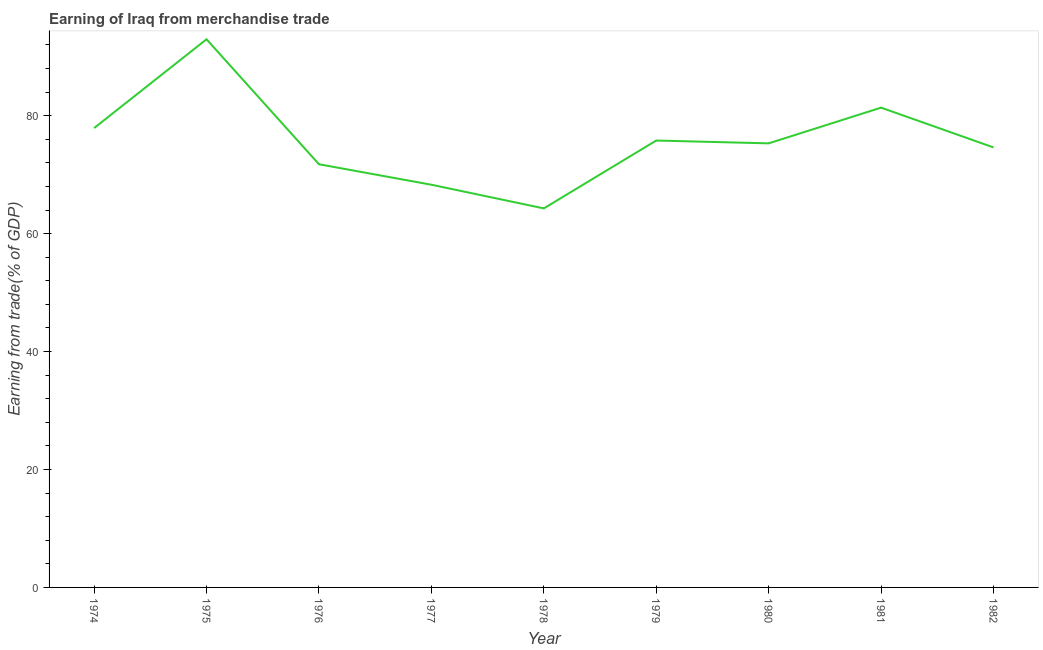What is the earning from merchandise trade in 1981?
Ensure brevity in your answer.  81.37. Across all years, what is the maximum earning from merchandise trade?
Ensure brevity in your answer.  92.96. Across all years, what is the minimum earning from merchandise trade?
Provide a succinct answer. 64.28. In which year was the earning from merchandise trade maximum?
Give a very brief answer. 1975. In which year was the earning from merchandise trade minimum?
Your response must be concise. 1978. What is the sum of the earning from merchandise trade?
Ensure brevity in your answer.  682.29. What is the difference between the earning from merchandise trade in 1977 and 1981?
Give a very brief answer. -13.07. What is the average earning from merchandise trade per year?
Offer a terse response. 75.81. What is the median earning from merchandise trade?
Make the answer very short. 75.31. Do a majority of the years between 1979 and 1981 (inclusive) have earning from merchandise trade greater than 40 %?
Ensure brevity in your answer.  Yes. What is the ratio of the earning from merchandise trade in 1974 to that in 1980?
Provide a short and direct response. 1.03. Is the earning from merchandise trade in 1977 less than that in 1981?
Make the answer very short. Yes. Is the difference between the earning from merchandise trade in 1977 and 1980 greater than the difference between any two years?
Give a very brief answer. No. What is the difference between the highest and the second highest earning from merchandise trade?
Keep it short and to the point. 11.59. Is the sum of the earning from merchandise trade in 1976 and 1980 greater than the maximum earning from merchandise trade across all years?
Your response must be concise. Yes. What is the difference between the highest and the lowest earning from merchandise trade?
Offer a terse response. 28.68. Does the earning from merchandise trade monotonically increase over the years?
Keep it short and to the point. No. How many lines are there?
Provide a short and direct response. 1. Are the values on the major ticks of Y-axis written in scientific E-notation?
Your answer should be compact. No. Does the graph contain any zero values?
Your response must be concise. No. Does the graph contain grids?
Make the answer very short. No. What is the title of the graph?
Offer a terse response. Earning of Iraq from merchandise trade. What is the label or title of the Y-axis?
Your answer should be compact. Earning from trade(% of GDP). What is the Earning from trade(% of GDP) of 1974?
Your answer should be compact. 77.9. What is the Earning from trade(% of GDP) of 1975?
Your answer should be very brief. 92.96. What is the Earning from trade(% of GDP) of 1976?
Make the answer very short. 71.77. What is the Earning from trade(% of GDP) of 1977?
Offer a terse response. 68.29. What is the Earning from trade(% of GDP) in 1978?
Your answer should be very brief. 64.28. What is the Earning from trade(% of GDP) in 1979?
Keep it short and to the point. 75.79. What is the Earning from trade(% of GDP) of 1980?
Make the answer very short. 75.31. What is the Earning from trade(% of GDP) of 1981?
Give a very brief answer. 81.37. What is the Earning from trade(% of GDP) of 1982?
Make the answer very short. 74.62. What is the difference between the Earning from trade(% of GDP) in 1974 and 1975?
Give a very brief answer. -15.06. What is the difference between the Earning from trade(% of GDP) in 1974 and 1976?
Offer a very short reply. 6.14. What is the difference between the Earning from trade(% of GDP) in 1974 and 1977?
Keep it short and to the point. 9.61. What is the difference between the Earning from trade(% of GDP) in 1974 and 1978?
Keep it short and to the point. 13.63. What is the difference between the Earning from trade(% of GDP) in 1974 and 1979?
Your response must be concise. 2.11. What is the difference between the Earning from trade(% of GDP) in 1974 and 1980?
Provide a succinct answer. 2.59. What is the difference between the Earning from trade(% of GDP) in 1974 and 1981?
Your response must be concise. -3.46. What is the difference between the Earning from trade(% of GDP) in 1974 and 1982?
Offer a terse response. 3.29. What is the difference between the Earning from trade(% of GDP) in 1975 and 1976?
Make the answer very short. 21.19. What is the difference between the Earning from trade(% of GDP) in 1975 and 1977?
Your answer should be very brief. 24.67. What is the difference between the Earning from trade(% of GDP) in 1975 and 1978?
Offer a very short reply. 28.68. What is the difference between the Earning from trade(% of GDP) in 1975 and 1979?
Ensure brevity in your answer.  17.17. What is the difference between the Earning from trade(% of GDP) in 1975 and 1980?
Offer a very short reply. 17.65. What is the difference between the Earning from trade(% of GDP) in 1975 and 1981?
Offer a very short reply. 11.59. What is the difference between the Earning from trade(% of GDP) in 1975 and 1982?
Provide a succinct answer. 18.34. What is the difference between the Earning from trade(% of GDP) in 1976 and 1977?
Offer a terse response. 3.47. What is the difference between the Earning from trade(% of GDP) in 1976 and 1978?
Your answer should be very brief. 7.49. What is the difference between the Earning from trade(% of GDP) in 1976 and 1979?
Ensure brevity in your answer.  -4.02. What is the difference between the Earning from trade(% of GDP) in 1976 and 1980?
Your answer should be compact. -3.54. What is the difference between the Earning from trade(% of GDP) in 1976 and 1981?
Provide a short and direct response. -9.6. What is the difference between the Earning from trade(% of GDP) in 1976 and 1982?
Your answer should be very brief. -2.85. What is the difference between the Earning from trade(% of GDP) in 1977 and 1978?
Give a very brief answer. 4.01. What is the difference between the Earning from trade(% of GDP) in 1977 and 1979?
Ensure brevity in your answer.  -7.5. What is the difference between the Earning from trade(% of GDP) in 1977 and 1980?
Ensure brevity in your answer.  -7.02. What is the difference between the Earning from trade(% of GDP) in 1977 and 1981?
Offer a terse response. -13.07. What is the difference between the Earning from trade(% of GDP) in 1977 and 1982?
Your response must be concise. -6.33. What is the difference between the Earning from trade(% of GDP) in 1978 and 1979?
Offer a very short reply. -11.51. What is the difference between the Earning from trade(% of GDP) in 1978 and 1980?
Keep it short and to the point. -11.03. What is the difference between the Earning from trade(% of GDP) in 1978 and 1981?
Keep it short and to the point. -17.09. What is the difference between the Earning from trade(% of GDP) in 1978 and 1982?
Give a very brief answer. -10.34. What is the difference between the Earning from trade(% of GDP) in 1979 and 1980?
Offer a very short reply. 0.48. What is the difference between the Earning from trade(% of GDP) in 1979 and 1981?
Provide a succinct answer. -5.58. What is the difference between the Earning from trade(% of GDP) in 1979 and 1982?
Keep it short and to the point. 1.17. What is the difference between the Earning from trade(% of GDP) in 1980 and 1981?
Your answer should be very brief. -6.06. What is the difference between the Earning from trade(% of GDP) in 1980 and 1982?
Make the answer very short. 0.69. What is the difference between the Earning from trade(% of GDP) in 1981 and 1982?
Provide a short and direct response. 6.75. What is the ratio of the Earning from trade(% of GDP) in 1974 to that in 1975?
Ensure brevity in your answer.  0.84. What is the ratio of the Earning from trade(% of GDP) in 1974 to that in 1976?
Provide a short and direct response. 1.09. What is the ratio of the Earning from trade(% of GDP) in 1974 to that in 1977?
Give a very brief answer. 1.14. What is the ratio of the Earning from trade(% of GDP) in 1974 to that in 1978?
Your response must be concise. 1.21. What is the ratio of the Earning from trade(% of GDP) in 1974 to that in 1979?
Give a very brief answer. 1.03. What is the ratio of the Earning from trade(% of GDP) in 1974 to that in 1980?
Your answer should be very brief. 1.03. What is the ratio of the Earning from trade(% of GDP) in 1974 to that in 1981?
Your answer should be very brief. 0.96. What is the ratio of the Earning from trade(% of GDP) in 1974 to that in 1982?
Your answer should be very brief. 1.04. What is the ratio of the Earning from trade(% of GDP) in 1975 to that in 1976?
Your answer should be compact. 1.29. What is the ratio of the Earning from trade(% of GDP) in 1975 to that in 1977?
Offer a very short reply. 1.36. What is the ratio of the Earning from trade(% of GDP) in 1975 to that in 1978?
Your answer should be compact. 1.45. What is the ratio of the Earning from trade(% of GDP) in 1975 to that in 1979?
Your answer should be compact. 1.23. What is the ratio of the Earning from trade(% of GDP) in 1975 to that in 1980?
Give a very brief answer. 1.23. What is the ratio of the Earning from trade(% of GDP) in 1975 to that in 1981?
Offer a terse response. 1.14. What is the ratio of the Earning from trade(% of GDP) in 1975 to that in 1982?
Provide a succinct answer. 1.25. What is the ratio of the Earning from trade(% of GDP) in 1976 to that in 1977?
Your answer should be very brief. 1.05. What is the ratio of the Earning from trade(% of GDP) in 1976 to that in 1978?
Your response must be concise. 1.12. What is the ratio of the Earning from trade(% of GDP) in 1976 to that in 1979?
Make the answer very short. 0.95. What is the ratio of the Earning from trade(% of GDP) in 1976 to that in 1980?
Offer a very short reply. 0.95. What is the ratio of the Earning from trade(% of GDP) in 1976 to that in 1981?
Give a very brief answer. 0.88. What is the ratio of the Earning from trade(% of GDP) in 1977 to that in 1978?
Your response must be concise. 1.06. What is the ratio of the Earning from trade(% of GDP) in 1977 to that in 1979?
Ensure brevity in your answer.  0.9. What is the ratio of the Earning from trade(% of GDP) in 1977 to that in 1980?
Give a very brief answer. 0.91. What is the ratio of the Earning from trade(% of GDP) in 1977 to that in 1981?
Make the answer very short. 0.84. What is the ratio of the Earning from trade(% of GDP) in 1977 to that in 1982?
Your answer should be compact. 0.92. What is the ratio of the Earning from trade(% of GDP) in 1978 to that in 1979?
Your answer should be compact. 0.85. What is the ratio of the Earning from trade(% of GDP) in 1978 to that in 1980?
Provide a succinct answer. 0.85. What is the ratio of the Earning from trade(% of GDP) in 1978 to that in 1981?
Make the answer very short. 0.79. What is the ratio of the Earning from trade(% of GDP) in 1978 to that in 1982?
Your answer should be very brief. 0.86. What is the ratio of the Earning from trade(% of GDP) in 1979 to that in 1982?
Provide a short and direct response. 1.02. What is the ratio of the Earning from trade(% of GDP) in 1980 to that in 1981?
Ensure brevity in your answer.  0.93. What is the ratio of the Earning from trade(% of GDP) in 1980 to that in 1982?
Provide a succinct answer. 1.01. What is the ratio of the Earning from trade(% of GDP) in 1981 to that in 1982?
Offer a very short reply. 1.09. 